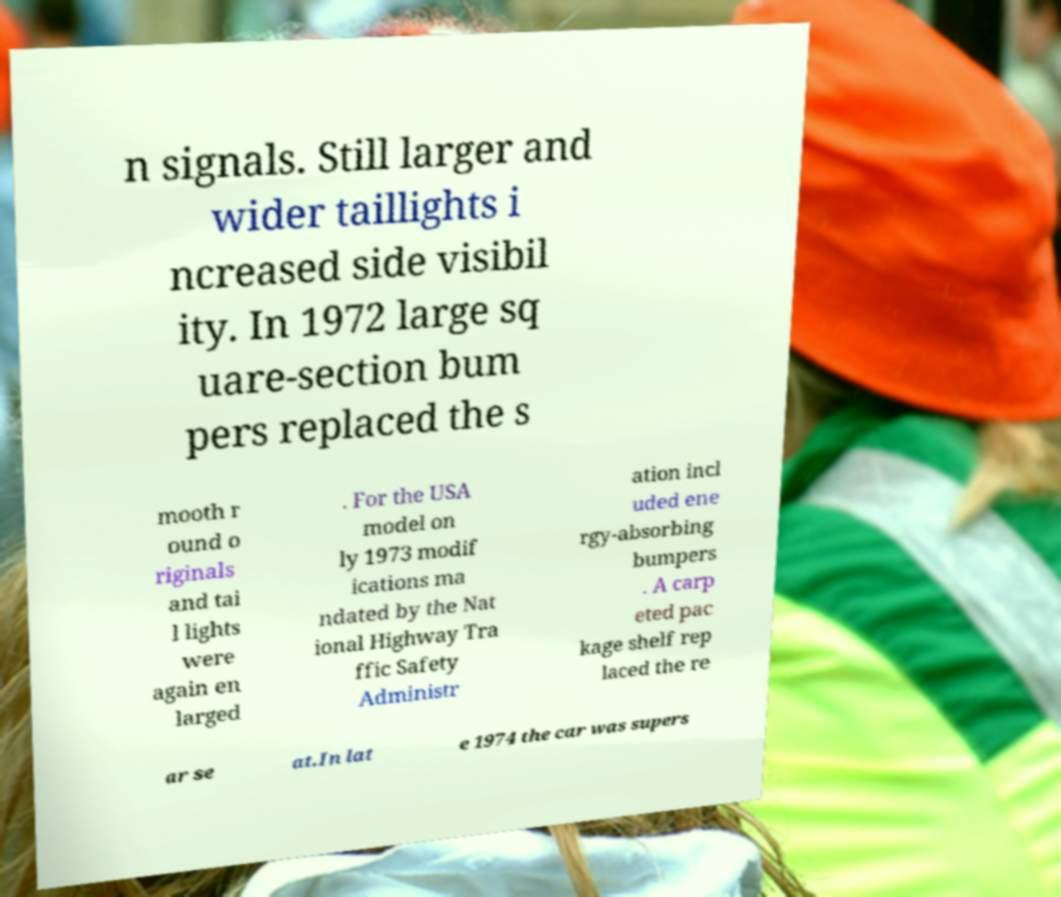Please identify and transcribe the text found in this image. n signals. Still larger and wider taillights i ncreased side visibil ity. In 1972 large sq uare-section bum pers replaced the s mooth r ound o riginals and tai l lights were again en larged . For the USA model on ly 1973 modif ications ma ndated by the Nat ional Highway Tra ffic Safety Administr ation incl uded ene rgy-absorbing bumpers . A carp eted pac kage shelf rep laced the re ar se at.In lat e 1974 the car was supers 